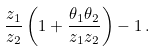<formula> <loc_0><loc_0><loc_500><loc_500>\frac { z _ { 1 } } { z _ { 2 } } \left ( 1 + \frac { \theta _ { 1 } \theta _ { 2 } } { z _ { 1 } z _ { 2 } } \right ) - 1 \, .</formula> 